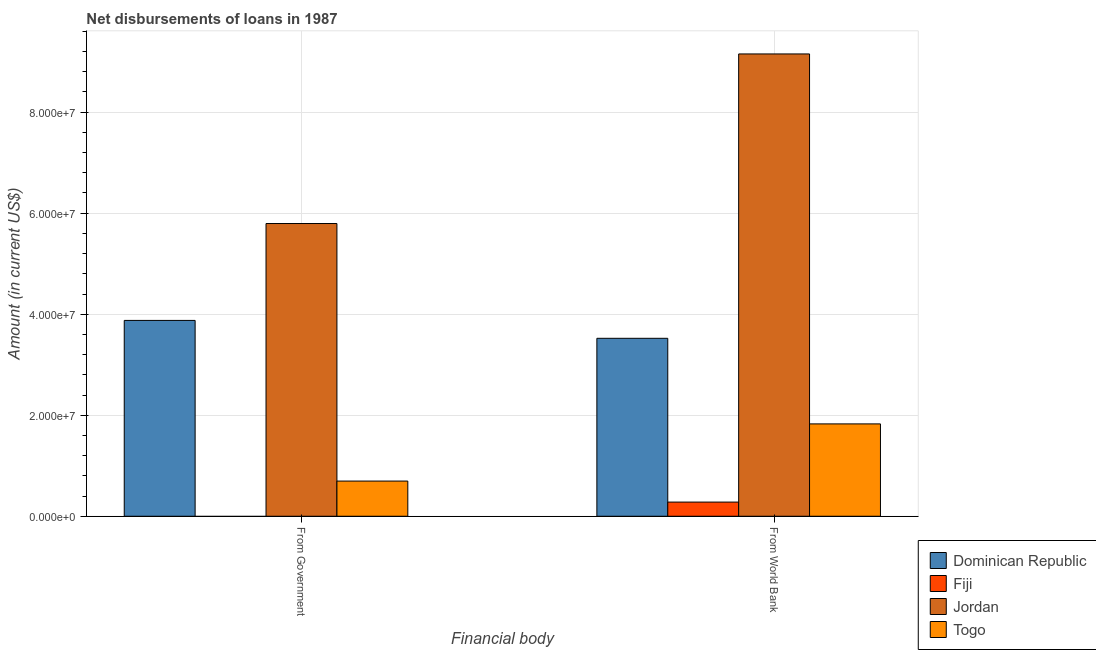How many different coloured bars are there?
Your answer should be very brief. 4. Are the number of bars per tick equal to the number of legend labels?
Provide a short and direct response. No. How many bars are there on the 1st tick from the left?
Offer a very short reply. 3. What is the label of the 1st group of bars from the left?
Make the answer very short. From Government. What is the net disbursements of loan from world bank in Dominican Republic?
Offer a terse response. 3.52e+07. Across all countries, what is the maximum net disbursements of loan from government?
Make the answer very short. 5.80e+07. Across all countries, what is the minimum net disbursements of loan from world bank?
Give a very brief answer. 2.80e+06. In which country was the net disbursements of loan from government maximum?
Give a very brief answer. Jordan. What is the total net disbursements of loan from world bank in the graph?
Offer a very short reply. 1.48e+08. What is the difference between the net disbursements of loan from government in Dominican Republic and that in Togo?
Your response must be concise. 3.18e+07. What is the difference between the net disbursements of loan from world bank in Togo and the net disbursements of loan from government in Jordan?
Your answer should be very brief. -3.97e+07. What is the average net disbursements of loan from world bank per country?
Your response must be concise. 3.70e+07. What is the difference between the net disbursements of loan from world bank and net disbursements of loan from government in Jordan?
Offer a terse response. 3.36e+07. What is the ratio of the net disbursements of loan from world bank in Dominican Republic to that in Fiji?
Give a very brief answer. 12.56. In how many countries, is the net disbursements of loan from government greater than the average net disbursements of loan from government taken over all countries?
Offer a terse response. 2. How many bars are there?
Ensure brevity in your answer.  7. Are all the bars in the graph horizontal?
Provide a short and direct response. No. How many countries are there in the graph?
Your response must be concise. 4. Does the graph contain any zero values?
Offer a very short reply. Yes. How many legend labels are there?
Offer a terse response. 4. What is the title of the graph?
Ensure brevity in your answer.  Net disbursements of loans in 1987. What is the label or title of the X-axis?
Your response must be concise. Financial body. What is the Amount (in current US$) of Dominican Republic in From Government?
Your answer should be compact. 3.88e+07. What is the Amount (in current US$) in Jordan in From Government?
Provide a succinct answer. 5.80e+07. What is the Amount (in current US$) of Togo in From Government?
Give a very brief answer. 6.97e+06. What is the Amount (in current US$) of Dominican Republic in From World Bank?
Offer a terse response. 3.52e+07. What is the Amount (in current US$) in Fiji in From World Bank?
Offer a terse response. 2.80e+06. What is the Amount (in current US$) of Jordan in From World Bank?
Your answer should be very brief. 9.15e+07. What is the Amount (in current US$) of Togo in From World Bank?
Make the answer very short. 1.83e+07. Across all Financial body, what is the maximum Amount (in current US$) of Dominican Republic?
Your answer should be compact. 3.88e+07. Across all Financial body, what is the maximum Amount (in current US$) of Fiji?
Offer a terse response. 2.80e+06. Across all Financial body, what is the maximum Amount (in current US$) of Jordan?
Your response must be concise. 9.15e+07. Across all Financial body, what is the maximum Amount (in current US$) of Togo?
Your answer should be compact. 1.83e+07. Across all Financial body, what is the minimum Amount (in current US$) of Dominican Republic?
Offer a terse response. 3.52e+07. Across all Financial body, what is the minimum Amount (in current US$) in Jordan?
Keep it short and to the point. 5.80e+07. Across all Financial body, what is the minimum Amount (in current US$) of Togo?
Provide a short and direct response. 6.97e+06. What is the total Amount (in current US$) in Dominican Republic in the graph?
Ensure brevity in your answer.  7.40e+07. What is the total Amount (in current US$) in Fiji in the graph?
Your response must be concise. 2.80e+06. What is the total Amount (in current US$) of Jordan in the graph?
Keep it short and to the point. 1.49e+08. What is the total Amount (in current US$) in Togo in the graph?
Give a very brief answer. 2.52e+07. What is the difference between the Amount (in current US$) of Dominican Republic in From Government and that in From World Bank?
Offer a very short reply. 3.54e+06. What is the difference between the Amount (in current US$) of Jordan in From Government and that in From World Bank?
Keep it short and to the point. -3.36e+07. What is the difference between the Amount (in current US$) in Togo in From Government and that in From World Bank?
Your answer should be compact. -1.13e+07. What is the difference between the Amount (in current US$) of Dominican Republic in From Government and the Amount (in current US$) of Fiji in From World Bank?
Give a very brief answer. 3.60e+07. What is the difference between the Amount (in current US$) in Dominican Republic in From Government and the Amount (in current US$) in Jordan in From World Bank?
Provide a succinct answer. -5.28e+07. What is the difference between the Amount (in current US$) of Dominican Republic in From Government and the Amount (in current US$) of Togo in From World Bank?
Make the answer very short. 2.05e+07. What is the difference between the Amount (in current US$) in Jordan in From Government and the Amount (in current US$) in Togo in From World Bank?
Keep it short and to the point. 3.97e+07. What is the average Amount (in current US$) in Dominican Republic per Financial body?
Your answer should be very brief. 3.70e+07. What is the average Amount (in current US$) of Fiji per Financial body?
Keep it short and to the point. 1.40e+06. What is the average Amount (in current US$) in Jordan per Financial body?
Provide a short and direct response. 7.47e+07. What is the average Amount (in current US$) in Togo per Financial body?
Your answer should be compact. 1.26e+07. What is the difference between the Amount (in current US$) in Dominican Republic and Amount (in current US$) in Jordan in From Government?
Ensure brevity in your answer.  -1.92e+07. What is the difference between the Amount (in current US$) of Dominican Republic and Amount (in current US$) of Togo in From Government?
Your answer should be very brief. 3.18e+07. What is the difference between the Amount (in current US$) in Jordan and Amount (in current US$) in Togo in From Government?
Your response must be concise. 5.10e+07. What is the difference between the Amount (in current US$) of Dominican Republic and Amount (in current US$) of Fiji in From World Bank?
Keep it short and to the point. 3.24e+07. What is the difference between the Amount (in current US$) of Dominican Republic and Amount (in current US$) of Jordan in From World Bank?
Offer a very short reply. -5.63e+07. What is the difference between the Amount (in current US$) in Dominican Republic and Amount (in current US$) in Togo in From World Bank?
Offer a terse response. 1.69e+07. What is the difference between the Amount (in current US$) of Fiji and Amount (in current US$) of Jordan in From World Bank?
Give a very brief answer. -8.87e+07. What is the difference between the Amount (in current US$) of Fiji and Amount (in current US$) of Togo in From World Bank?
Ensure brevity in your answer.  -1.55e+07. What is the difference between the Amount (in current US$) of Jordan and Amount (in current US$) of Togo in From World Bank?
Your answer should be very brief. 7.32e+07. What is the ratio of the Amount (in current US$) of Dominican Republic in From Government to that in From World Bank?
Ensure brevity in your answer.  1.1. What is the ratio of the Amount (in current US$) of Jordan in From Government to that in From World Bank?
Keep it short and to the point. 0.63. What is the ratio of the Amount (in current US$) in Togo in From Government to that in From World Bank?
Ensure brevity in your answer.  0.38. What is the difference between the highest and the second highest Amount (in current US$) in Dominican Republic?
Offer a terse response. 3.54e+06. What is the difference between the highest and the second highest Amount (in current US$) in Jordan?
Ensure brevity in your answer.  3.36e+07. What is the difference between the highest and the second highest Amount (in current US$) in Togo?
Your answer should be very brief. 1.13e+07. What is the difference between the highest and the lowest Amount (in current US$) of Dominican Republic?
Your response must be concise. 3.54e+06. What is the difference between the highest and the lowest Amount (in current US$) in Fiji?
Offer a terse response. 2.80e+06. What is the difference between the highest and the lowest Amount (in current US$) in Jordan?
Make the answer very short. 3.36e+07. What is the difference between the highest and the lowest Amount (in current US$) in Togo?
Your response must be concise. 1.13e+07. 